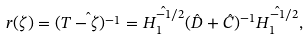<formula> <loc_0><loc_0><loc_500><loc_500>r ( \zeta ) = \hat { ( T - \zeta ) ^ { - 1 } } = \hat { H _ { 1 } ^ { - 1 / 2 } } ( \hat { D } + \hat { C } ) ^ { - 1 } \hat { H _ { 1 } ^ { - 1 / 2 } } ,</formula> 